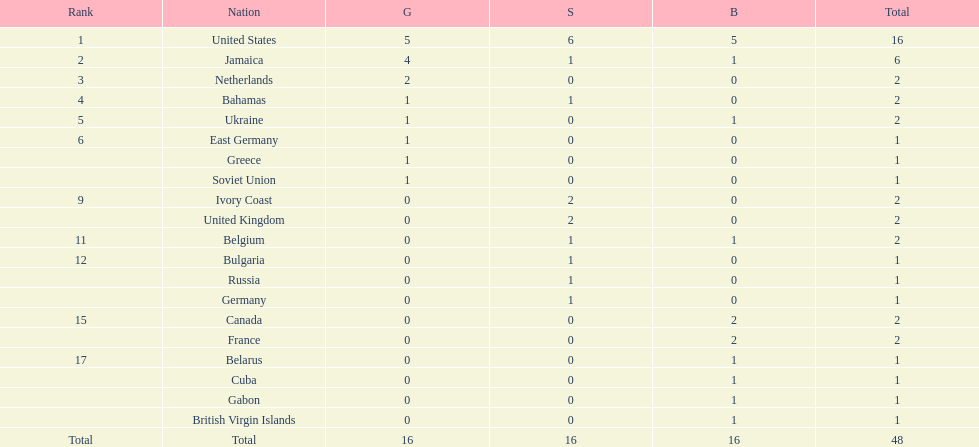Could you parse the entire table as a dict? {'header': ['Rank', 'Nation', 'G', 'S', 'B', 'Total'], 'rows': [['1', 'United States', '5', '6', '5', '16'], ['2', 'Jamaica', '4', '1', '1', '6'], ['3', 'Netherlands', '2', '0', '0', '2'], ['4', 'Bahamas', '1', '1', '0', '2'], ['5', 'Ukraine', '1', '0', '1', '2'], ['6', 'East Germany', '1', '0', '0', '1'], ['', 'Greece', '1', '0', '0', '1'], ['', 'Soviet Union', '1', '0', '0', '1'], ['9', 'Ivory Coast', '0', '2', '0', '2'], ['', 'United Kingdom', '0', '2', '0', '2'], ['11', 'Belgium', '0', '1', '1', '2'], ['12', 'Bulgaria', '0', '1', '0', '1'], ['', 'Russia', '0', '1', '0', '1'], ['', 'Germany', '0', '1', '0', '1'], ['15', 'Canada', '0', '0', '2', '2'], ['', 'France', '0', '0', '2', '2'], ['17', 'Belarus', '0', '0', '1', '1'], ['', 'Cuba', '0', '0', '1', '1'], ['', 'Gabon', '0', '0', '1', '1'], ['', 'British Virgin Islands', '0', '0', '1', '1'], ['Total', 'Total', '16', '16', '16', '48']]} How many gold medals did the us and jamaica win combined? 9. 